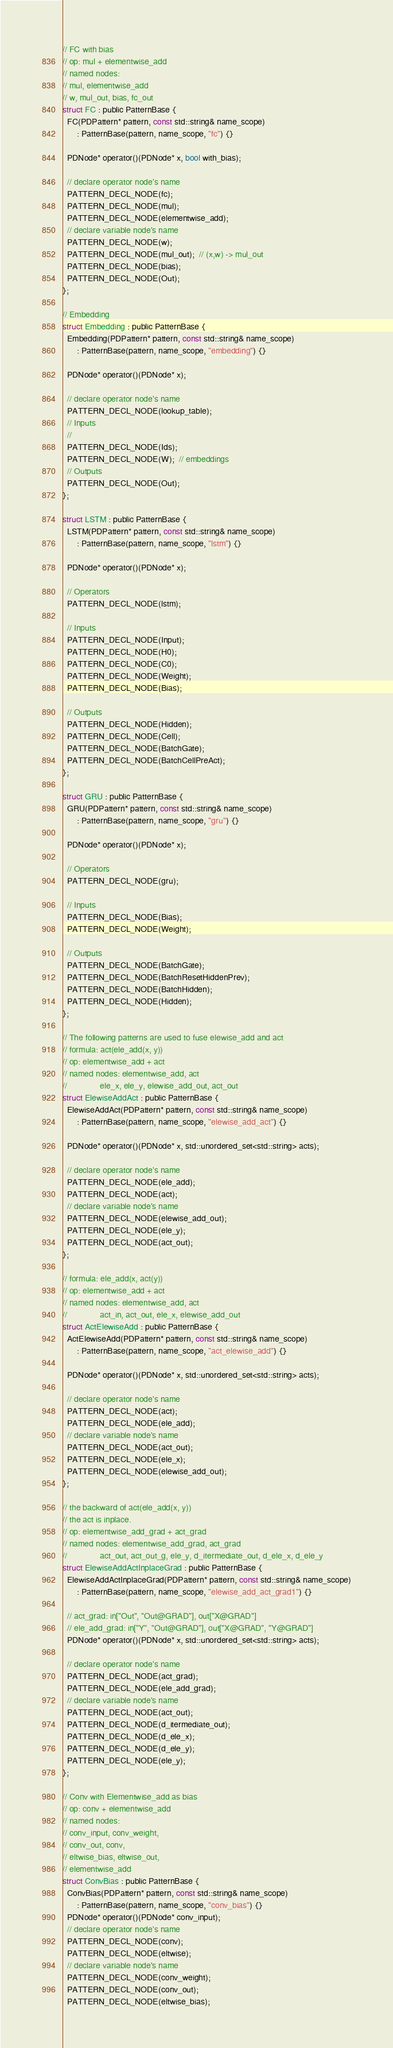Convert code to text. <code><loc_0><loc_0><loc_500><loc_500><_C_>
// FC with bias
// op: mul + elementwise_add
// named nodes:
// mul, elementwise_add
// w, mul_out, bias, fc_out
struct FC : public PatternBase {
  FC(PDPattern* pattern, const std::string& name_scope)
      : PatternBase(pattern, name_scope, "fc") {}

  PDNode* operator()(PDNode* x, bool with_bias);

  // declare operator node's name
  PATTERN_DECL_NODE(fc);
  PATTERN_DECL_NODE(mul);
  PATTERN_DECL_NODE(elementwise_add);
  // declare variable node's name
  PATTERN_DECL_NODE(w);
  PATTERN_DECL_NODE(mul_out);  // (x,w) -> mul_out
  PATTERN_DECL_NODE(bias);
  PATTERN_DECL_NODE(Out);
};

// Embedding
struct Embedding : public PatternBase {
  Embedding(PDPattern* pattern, const std::string& name_scope)
      : PatternBase(pattern, name_scope, "embedding") {}

  PDNode* operator()(PDNode* x);

  // declare operator node's name
  PATTERN_DECL_NODE(lookup_table);
  // Inputs
  //
  PATTERN_DECL_NODE(Ids);
  PATTERN_DECL_NODE(W);  // embeddings
  // Outputs
  PATTERN_DECL_NODE(Out);
};

struct LSTM : public PatternBase {
  LSTM(PDPattern* pattern, const std::string& name_scope)
      : PatternBase(pattern, name_scope, "lstm") {}

  PDNode* operator()(PDNode* x);

  // Operators
  PATTERN_DECL_NODE(lstm);

  // Inputs
  PATTERN_DECL_NODE(Input);
  PATTERN_DECL_NODE(H0);
  PATTERN_DECL_NODE(C0);
  PATTERN_DECL_NODE(Weight);
  PATTERN_DECL_NODE(Bias);

  // Outputs
  PATTERN_DECL_NODE(Hidden);
  PATTERN_DECL_NODE(Cell);
  PATTERN_DECL_NODE(BatchGate);
  PATTERN_DECL_NODE(BatchCellPreAct);
};

struct GRU : public PatternBase {
  GRU(PDPattern* pattern, const std::string& name_scope)
      : PatternBase(pattern, name_scope, "gru") {}

  PDNode* operator()(PDNode* x);

  // Operators
  PATTERN_DECL_NODE(gru);

  // Inputs
  PATTERN_DECL_NODE(Bias);
  PATTERN_DECL_NODE(Weight);

  // Outputs
  PATTERN_DECL_NODE(BatchGate);
  PATTERN_DECL_NODE(BatchResetHiddenPrev);
  PATTERN_DECL_NODE(BatchHidden);
  PATTERN_DECL_NODE(Hidden);
};

// The following patterns are used to fuse elewise_add and act
// formula: act(ele_add(x, y))
// op: elementwise_add + act
// named nodes: elementwise_add, act
//              ele_x, ele_y, elewise_add_out, act_out
struct ElewiseAddAct : public PatternBase {
  ElewiseAddAct(PDPattern* pattern, const std::string& name_scope)
      : PatternBase(pattern, name_scope, "elewise_add_act") {}

  PDNode* operator()(PDNode* x, std::unordered_set<std::string> acts);

  // declare operator node's name
  PATTERN_DECL_NODE(ele_add);
  PATTERN_DECL_NODE(act);
  // declare variable node's name
  PATTERN_DECL_NODE(elewise_add_out);
  PATTERN_DECL_NODE(ele_y);
  PATTERN_DECL_NODE(act_out);
};

// formula: ele_add(x, act(y))
// op: elementwise_add + act
// named nodes: elementwise_add, act
//              act_in, act_out, ele_x, elewise_add_out
struct ActElewiseAdd : public PatternBase {
  ActElewiseAdd(PDPattern* pattern, const std::string& name_scope)
      : PatternBase(pattern, name_scope, "act_elewise_add") {}

  PDNode* operator()(PDNode* x, std::unordered_set<std::string> acts);

  // declare operator node's name
  PATTERN_DECL_NODE(act);
  PATTERN_DECL_NODE(ele_add);
  // declare variable node's name
  PATTERN_DECL_NODE(act_out);
  PATTERN_DECL_NODE(ele_x);
  PATTERN_DECL_NODE(elewise_add_out);
};

// the backward of act(ele_add(x, y))
// the act is inplace.
// op: elementwise_add_grad + act_grad
// named nodes: elementwise_add_grad, act_grad
//              act_out, act_out_g, ele_y, d_itermediate_out, d_ele_x, d_ele_y
struct ElewiseAddActInplaceGrad : public PatternBase {
  ElewiseAddActInplaceGrad(PDPattern* pattern, const std::string& name_scope)
      : PatternBase(pattern, name_scope, "elewise_add_act_grad1") {}

  // act_grad: in["Out", "Out@GRAD"], out["X@GRAD"]
  // ele_add_grad: in["Y", "Out@GRAD"], out["X@GRAD", "Y@GRAD"]
  PDNode* operator()(PDNode* x, std::unordered_set<std::string> acts);

  // declare operator node's name
  PATTERN_DECL_NODE(act_grad);
  PATTERN_DECL_NODE(ele_add_grad);
  // declare variable node's name
  PATTERN_DECL_NODE(act_out);
  PATTERN_DECL_NODE(d_itermediate_out);
  PATTERN_DECL_NODE(d_ele_x);
  PATTERN_DECL_NODE(d_ele_y);
  PATTERN_DECL_NODE(ele_y);
};

// Conv with Elementwise_add as bias
// op: conv + elementwise_add
// named nodes:
// conv_input, conv_weight,
// conv_out, conv,
// eltwise_bias, eltwise_out,
// elementwise_add
struct ConvBias : public PatternBase {
  ConvBias(PDPattern* pattern, const std::string& name_scope)
      : PatternBase(pattern, name_scope, "conv_bias") {}
  PDNode* operator()(PDNode* conv_input);
  // declare operator node's name
  PATTERN_DECL_NODE(conv);
  PATTERN_DECL_NODE(eltwise);
  // declare variable node's name
  PATTERN_DECL_NODE(conv_weight);
  PATTERN_DECL_NODE(conv_out);
  PATTERN_DECL_NODE(eltwise_bias);</code> 